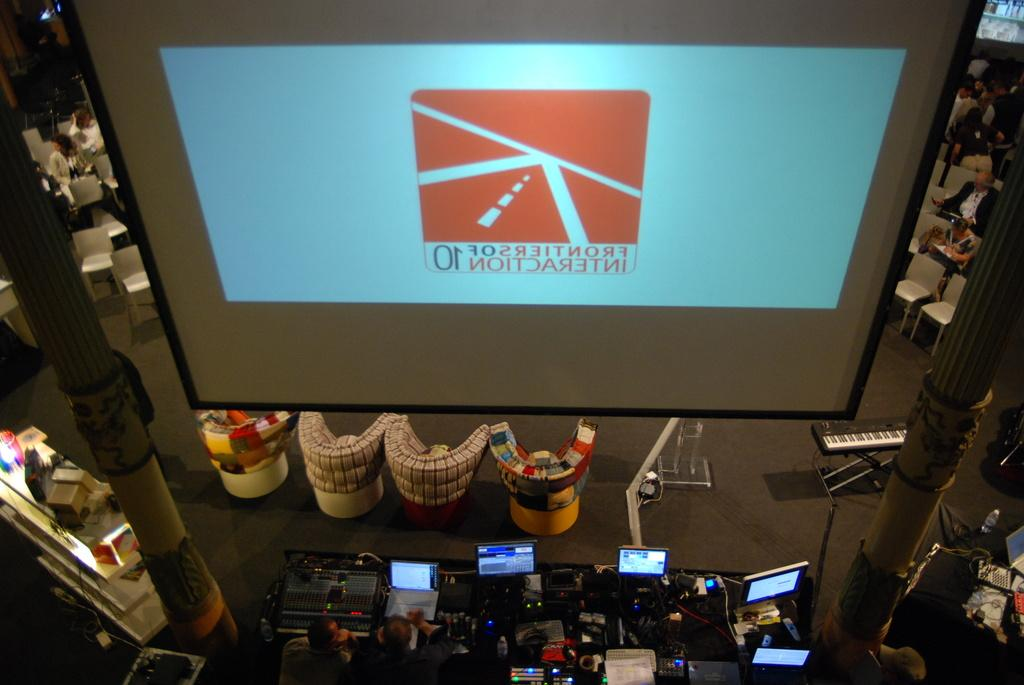Provide a one-sentence caption for the provided image. Lettering appears backwards on a screen and has the numbers 01 below a picture of a road. 